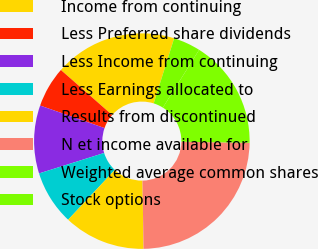Convert chart. <chart><loc_0><loc_0><loc_500><loc_500><pie_chart><fcel>Income from continuing<fcel>Less Preferred share dividends<fcel>Less Income from continuing<fcel>Less Earnings allocated to<fcel>Results from discontinued<fcel>N et income available for<fcel>Weighted average common shares<fcel>Stock options<nl><fcel>18.37%<fcel>6.12%<fcel>10.2%<fcel>8.16%<fcel>12.24%<fcel>24.49%<fcel>16.33%<fcel>4.08%<nl></chart> 